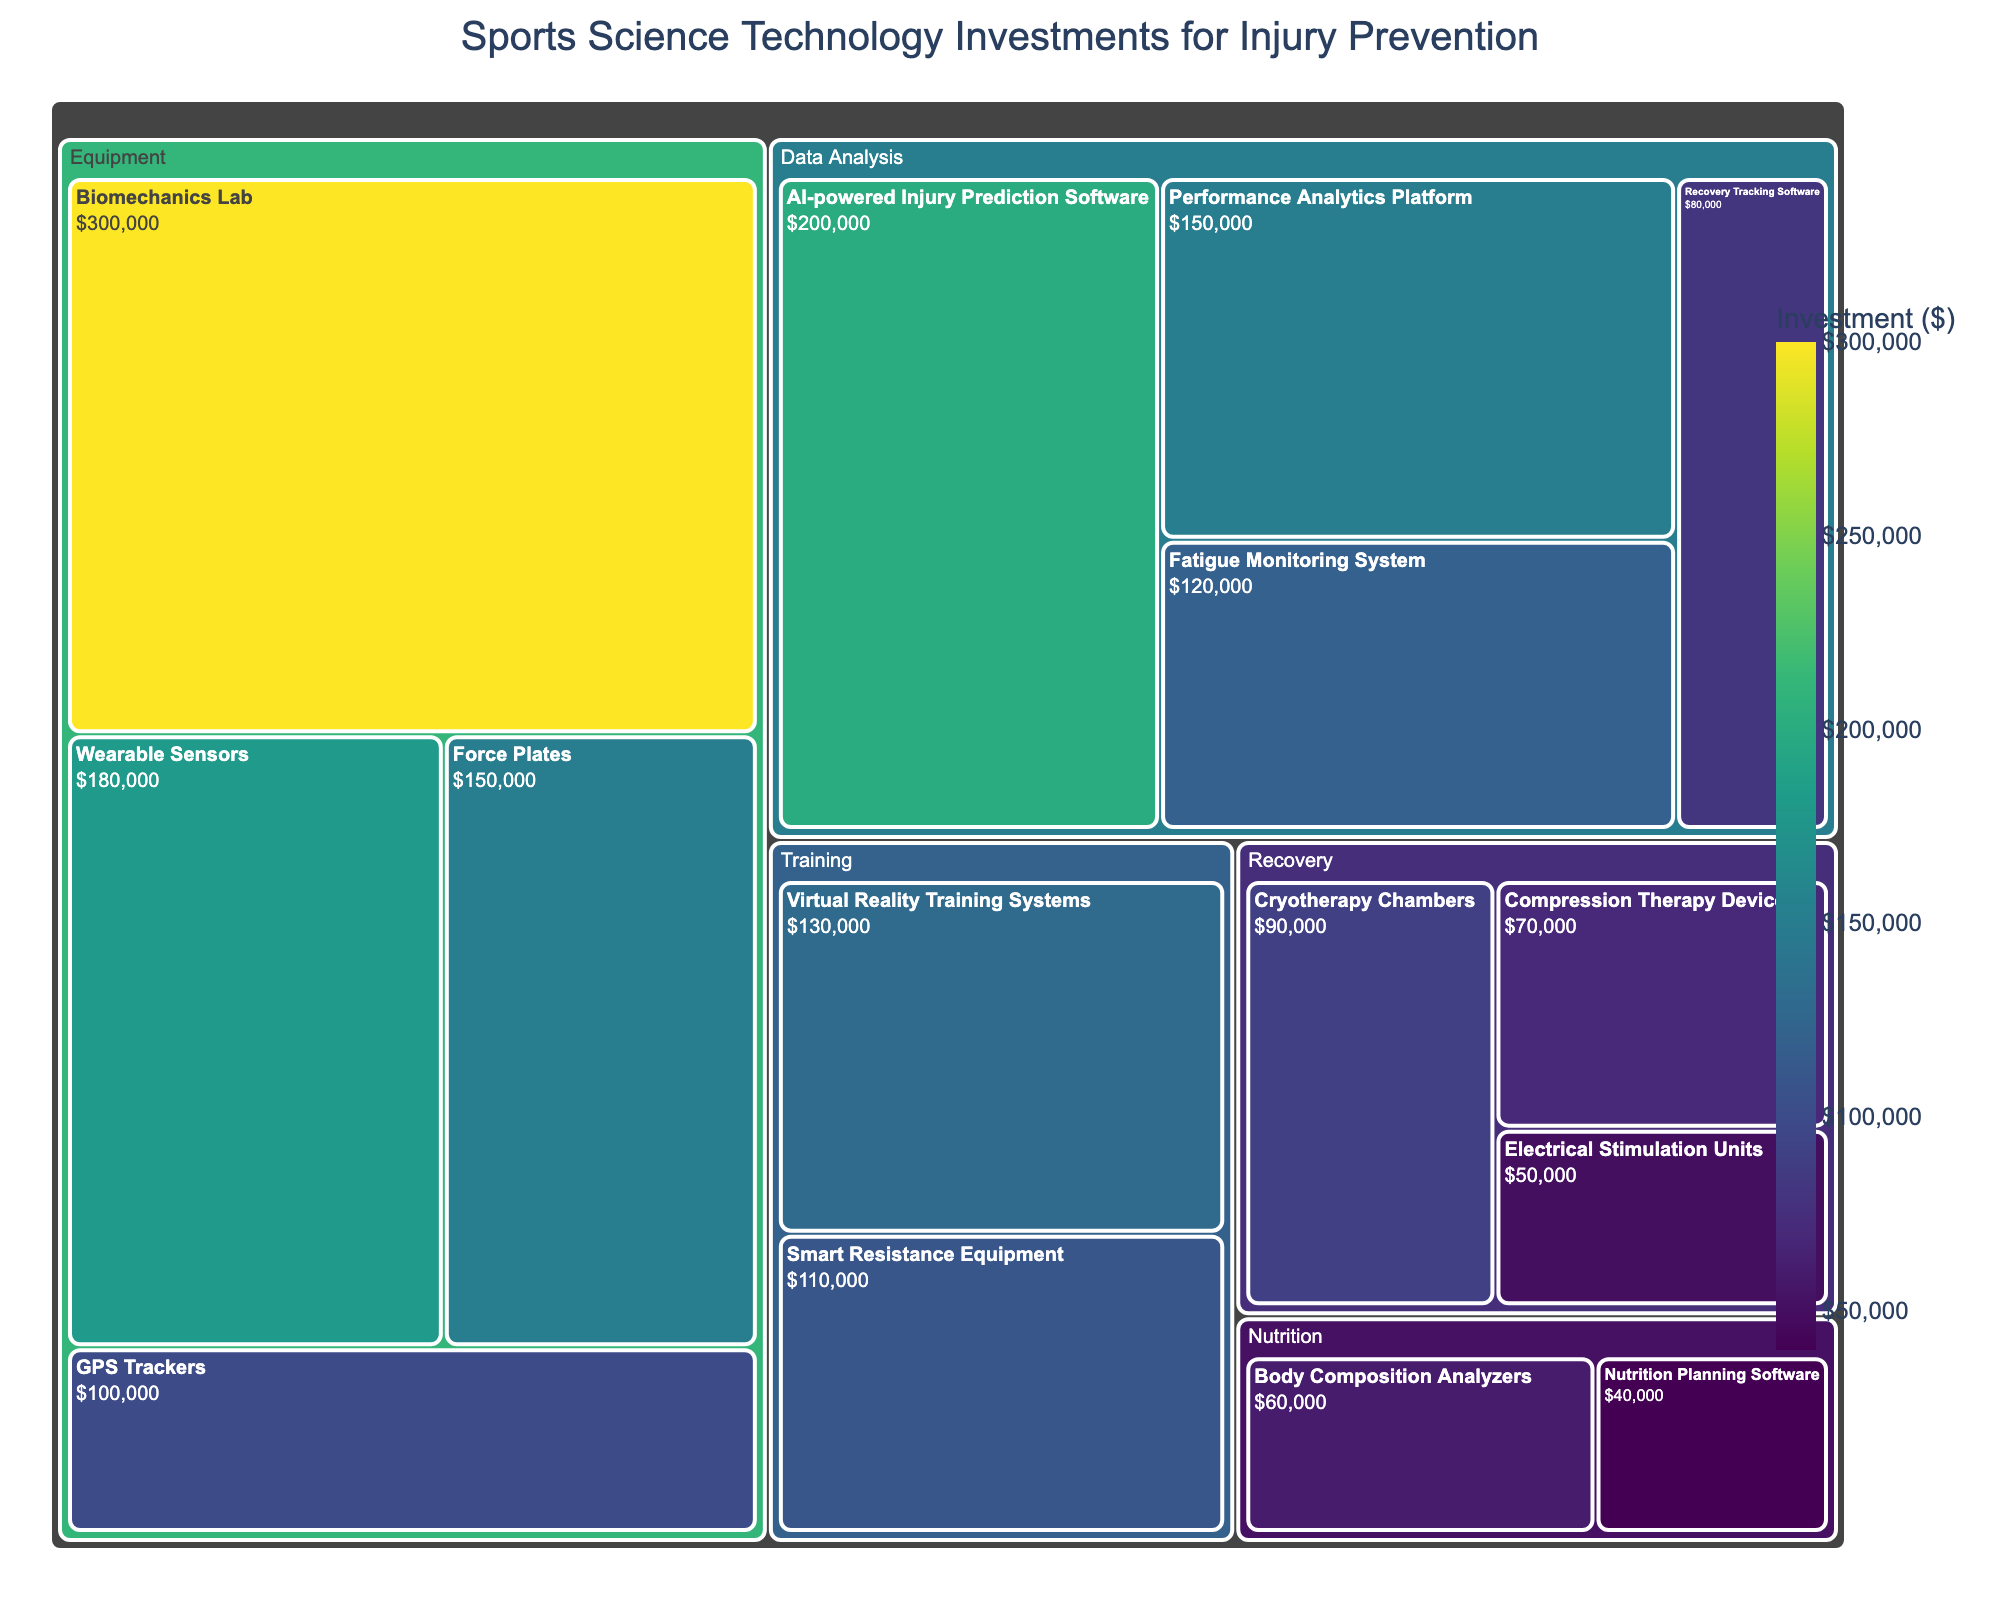What's the main category with the highest investment? To find the main category with the highest investment, we observe the breakdown of the largest segments within the Treemap. 'Equipment' represents the largest section.
Answer: Equipment Which subcategory within 'Data Analysis' has the smallest investment? To identify the subcategory within 'Data Analysis' with the smallest investment, visually compare the sizes and investment values of each subcategory under 'Data Analysis.' 'Recovery' Tracking Software' has the smallest value of $80,000.
Answer: Recovery Tracking Software What's the combined investment in 'Recovery' and 'Nutrition'? To find the combined investment, sum the investments for all subcategories under 'Recovery' and 'Nutrition' (Recovery: $90,000 + $70,000 + $50,000 = $210,000; Nutrition: $60,000 + $40,000 = $100,000). Sum $210,000 and $100,000 to get $310,000.
Answer: $310,000 Which category has a higher total investment, 'Training' or 'Nutrition'? Compare the sum of the investments in each subcategory under 'Training' ($110,000 + $130,000 = $240,000) to 'Nutrition' ($60,000 + $40,000 = $100,000). 'Training' has a higher total investment.
Answer: Training Is the investment in 'Wearable Sensors' greater than that in 'Cryotherapy Chambers'? Compare the investment values: 'Wearable Sensors' ($180,000) and 'Cryotherapy Chambers' ($90,000). Yes, 'Wearable Sensors' has a greater investment.
Answer: Yes What's the average investment in the 'Equipment' category? Calculate the average by summing the investments for all subcategories under 'Equipment' ($150,000 + $100,000 + $180,000 + $300,000 = $730,000). Divide this by the number of subcategories (4). Average is $730,000 / 4 = $182,500.
Answer: $182,500 Which subcategory within 'Equipment' receives the most investment? Observe the 'Equipment' category and identify the largest segment, which is the 'Biomechanics Lab' with an investment of $300,000.
Answer: Biomechanics Lab What's the total investment in 'Data Analysis'? Sum the investments for all subcategories under 'Data Analysis' ($200,000 + $150,000 + $120,000 + $80,000), which totals $550,000.
Answer: $550,000 Compare the total investments in 'Force Plates' and 'Virtual Reality Training Systems'. Which is higher? Compare the amounts directly: 'Force Plates' ($150,000) and 'Virtual Reality Training Systems' ($130,000). 'Force Plates' has the higher investment.
Answer: Force Plates What's the smallest subcategory investment across all categories? Identify the smallest segment within the entire Treemap, which is 'Electrical Stimulation Units' under 'Recovery' with an investment of $50,000.
Answer: Electrical Stimulation Units 